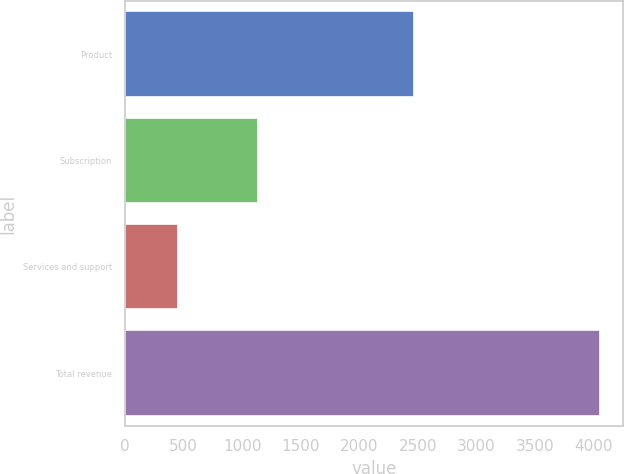<chart> <loc_0><loc_0><loc_500><loc_500><bar_chart><fcel>Product<fcel>Subscription<fcel>Services and support<fcel>Total revenue<nl><fcel>2470.1<fcel>1137.9<fcel>447.2<fcel>4055.2<nl></chart> 